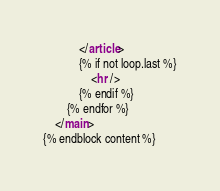<code> <loc_0><loc_0><loc_500><loc_500><_HTML_>            </article>
            {% if not loop.last %}
                <hr />
            {% endif %}
        {% endfor %}
    </main>
{% endblock content %}
</code> 